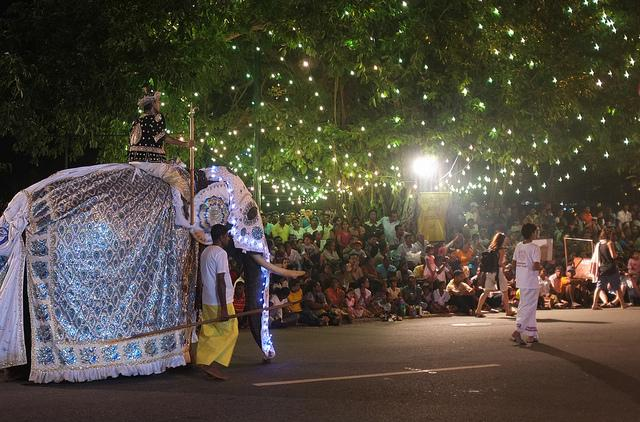Which part of the animal is precious?

Choices:
A) ivory
B) skin
C) nose
D) cape ivory 